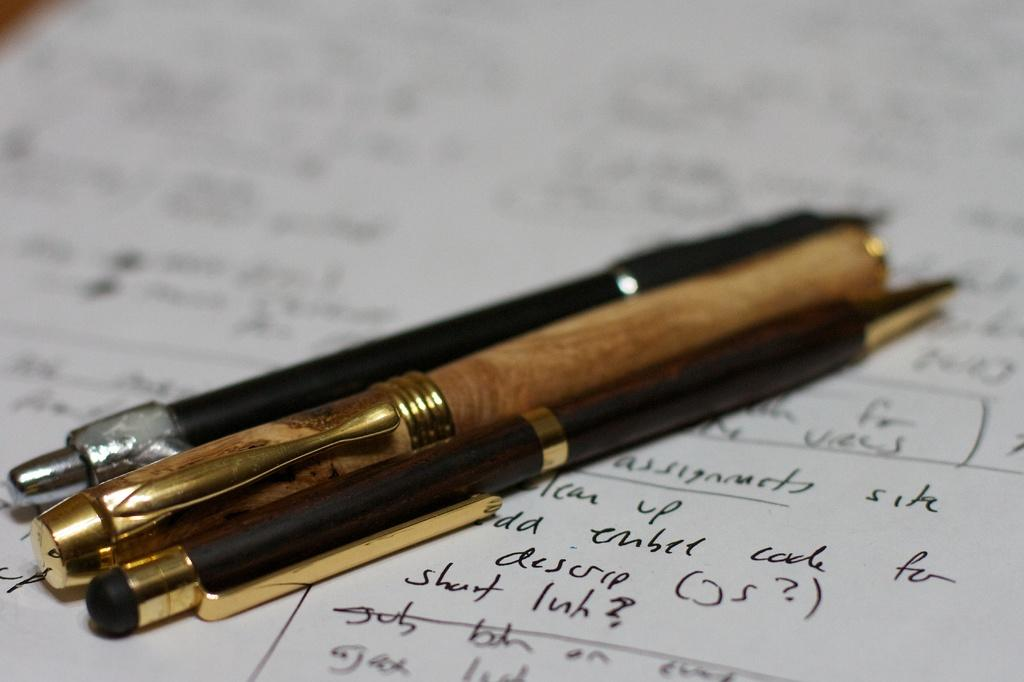<image>
Present a compact description of the photo's key features. Three pens on a sheet of paper with a bunch of writing including a line that say descr. 